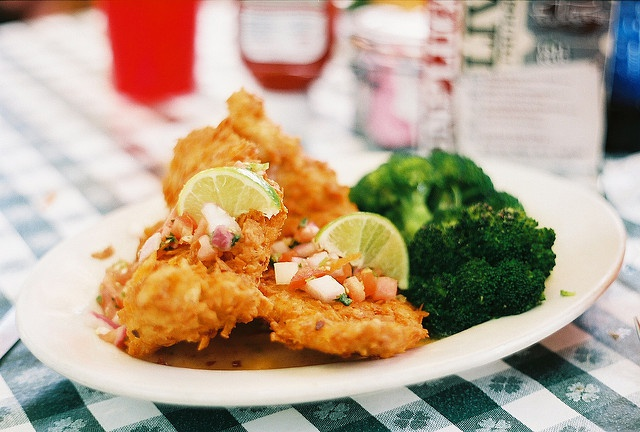Describe the objects in this image and their specific colors. I can see dining table in lightgray, black, darkgray, orange, and pink tones, broccoli in black, darkgreen, and beige tones, broccoli in black, darkgreen, and green tones, cup in black, red, salmon, and lightpink tones, and bottle in black, lightgray, pink, and brown tones in this image. 